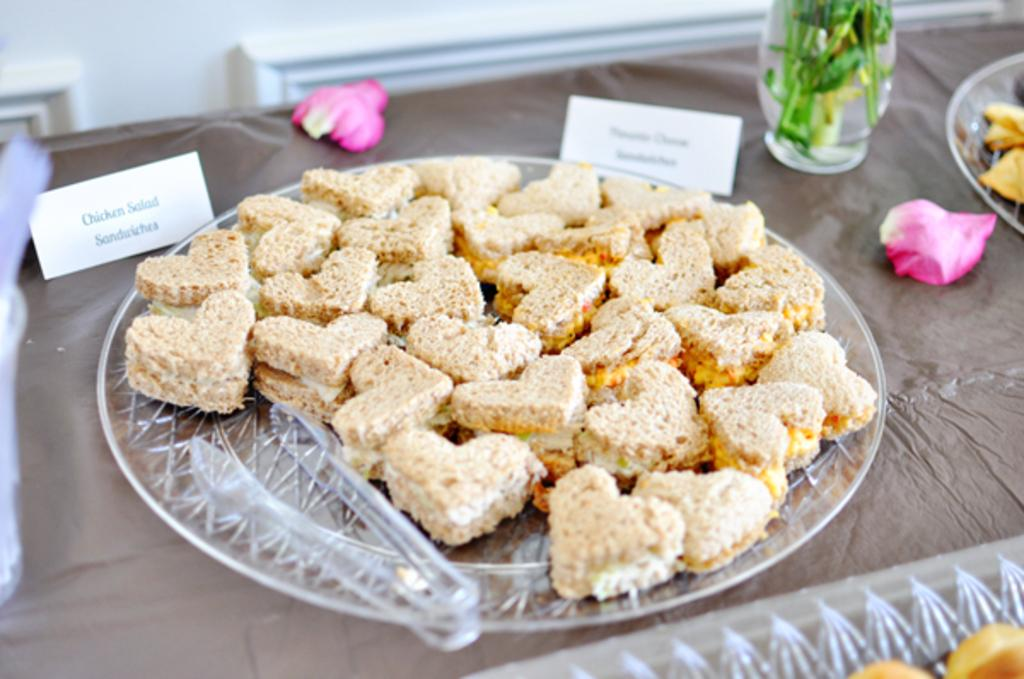What piece of furniture is present in the image? There is a table in the image. What is on the table? There is a plate of snacks and another plate on the table. What is beside the plate of snacks? There is a pot beside the plate of snacks. What additional item can be seen in the image? There is a nameplate in the image. What decorative element is present in the image? There are rose petals in the image. What actor is performing on the table in the image? There is no actor performing on the table in the image; it is a still image with no action taking place. What is the secretary doing in the image? There is no secretary present in the image. 